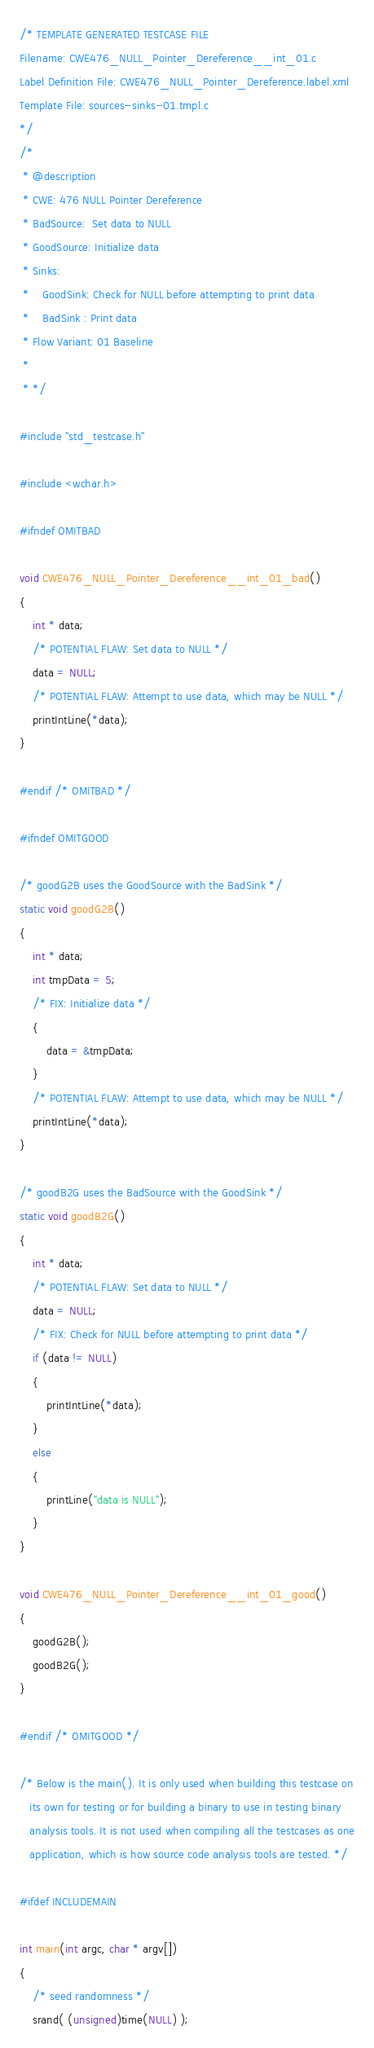<code> <loc_0><loc_0><loc_500><loc_500><_C_>/* TEMPLATE GENERATED TESTCASE FILE
Filename: CWE476_NULL_Pointer_Dereference__int_01.c
Label Definition File: CWE476_NULL_Pointer_Dereference.label.xml
Template File: sources-sinks-01.tmpl.c
*/
/*
 * @description
 * CWE: 476 NULL Pointer Dereference
 * BadSource:  Set data to NULL
 * GoodSource: Initialize data
 * Sinks:
 *    GoodSink: Check for NULL before attempting to print data
 *    BadSink : Print data
 * Flow Variant: 01 Baseline
 *
 * */

#include "std_testcase.h"

#include <wchar.h>

#ifndef OMITBAD

void CWE476_NULL_Pointer_Dereference__int_01_bad()
{
    int * data;
    /* POTENTIAL FLAW: Set data to NULL */
    data = NULL;
    /* POTENTIAL FLAW: Attempt to use data, which may be NULL */
    printIntLine(*data);
}

#endif /* OMITBAD */

#ifndef OMITGOOD

/* goodG2B uses the GoodSource with the BadSink */
static void goodG2B()
{
    int * data;
    int tmpData = 5;
    /* FIX: Initialize data */
    {
        data = &tmpData;
    }
    /* POTENTIAL FLAW: Attempt to use data, which may be NULL */
    printIntLine(*data);
}

/* goodB2G uses the BadSource with the GoodSink */
static void goodB2G()
{
    int * data;
    /* POTENTIAL FLAW: Set data to NULL */
    data = NULL;
    /* FIX: Check for NULL before attempting to print data */
    if (data != NULL)
    {
        printIntLine(*data);
    }
    else
    {
        printLine("data is NULL");
    }
}

void CWE476_NULL_Pointer_Dereference__int_01_good()
{
    goodG2B();
    goodB2G();
}

#endif /* OMITGOOD */

/* Below is the main(). It is only used when building this testcase on
   its own for testing or for building a binary to use in testing binary
   analysis tools. It is not used when compiling all the testcases as one
   application, which is how source code analysis tools are tested. */

#ifdef INCLUDEMAIN

int main(int argc, char * argv[])
{
    /* seed randomness */
    srand( (unsigned)time(NULL) );</code> 